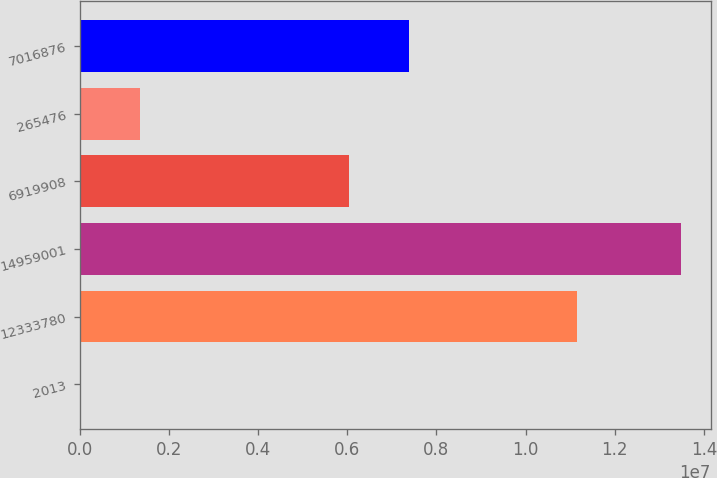Convert chart to OTSL. <chart><loc_0><loc_0><loc_500><loc_500><bar_chart><fcel>2013<fcel>12333780<fcel>14959001<fcel>6919908<fcel>265476<fcel>7016876<nl><fcel>2011<fcel>1.11472e+07<fcel>1.34839e+07<fcel>6.0354e+06<fcel>1.3502e+06<fcel>7.38358e+06<nl></chart> 